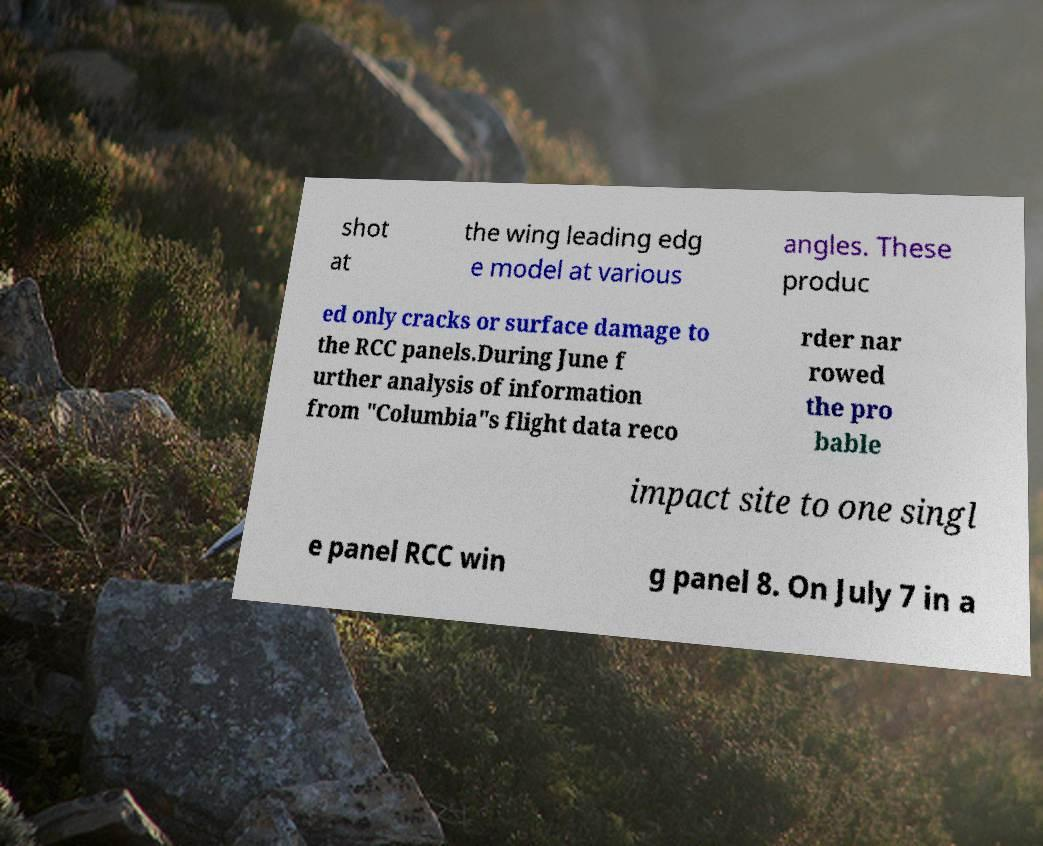There's text embedded in this image that I need extracted. Can you transcribe it verbatim? shot at the wing leading edg e model at various angles. These produc ed only cracks or surface damage to the RCC panels.During June f urther analysis of information from "Columbia"s flight data reco rder nar rowed the pro bable impact site to one singl e panel RCC win g panel 8. On July 7 in a 